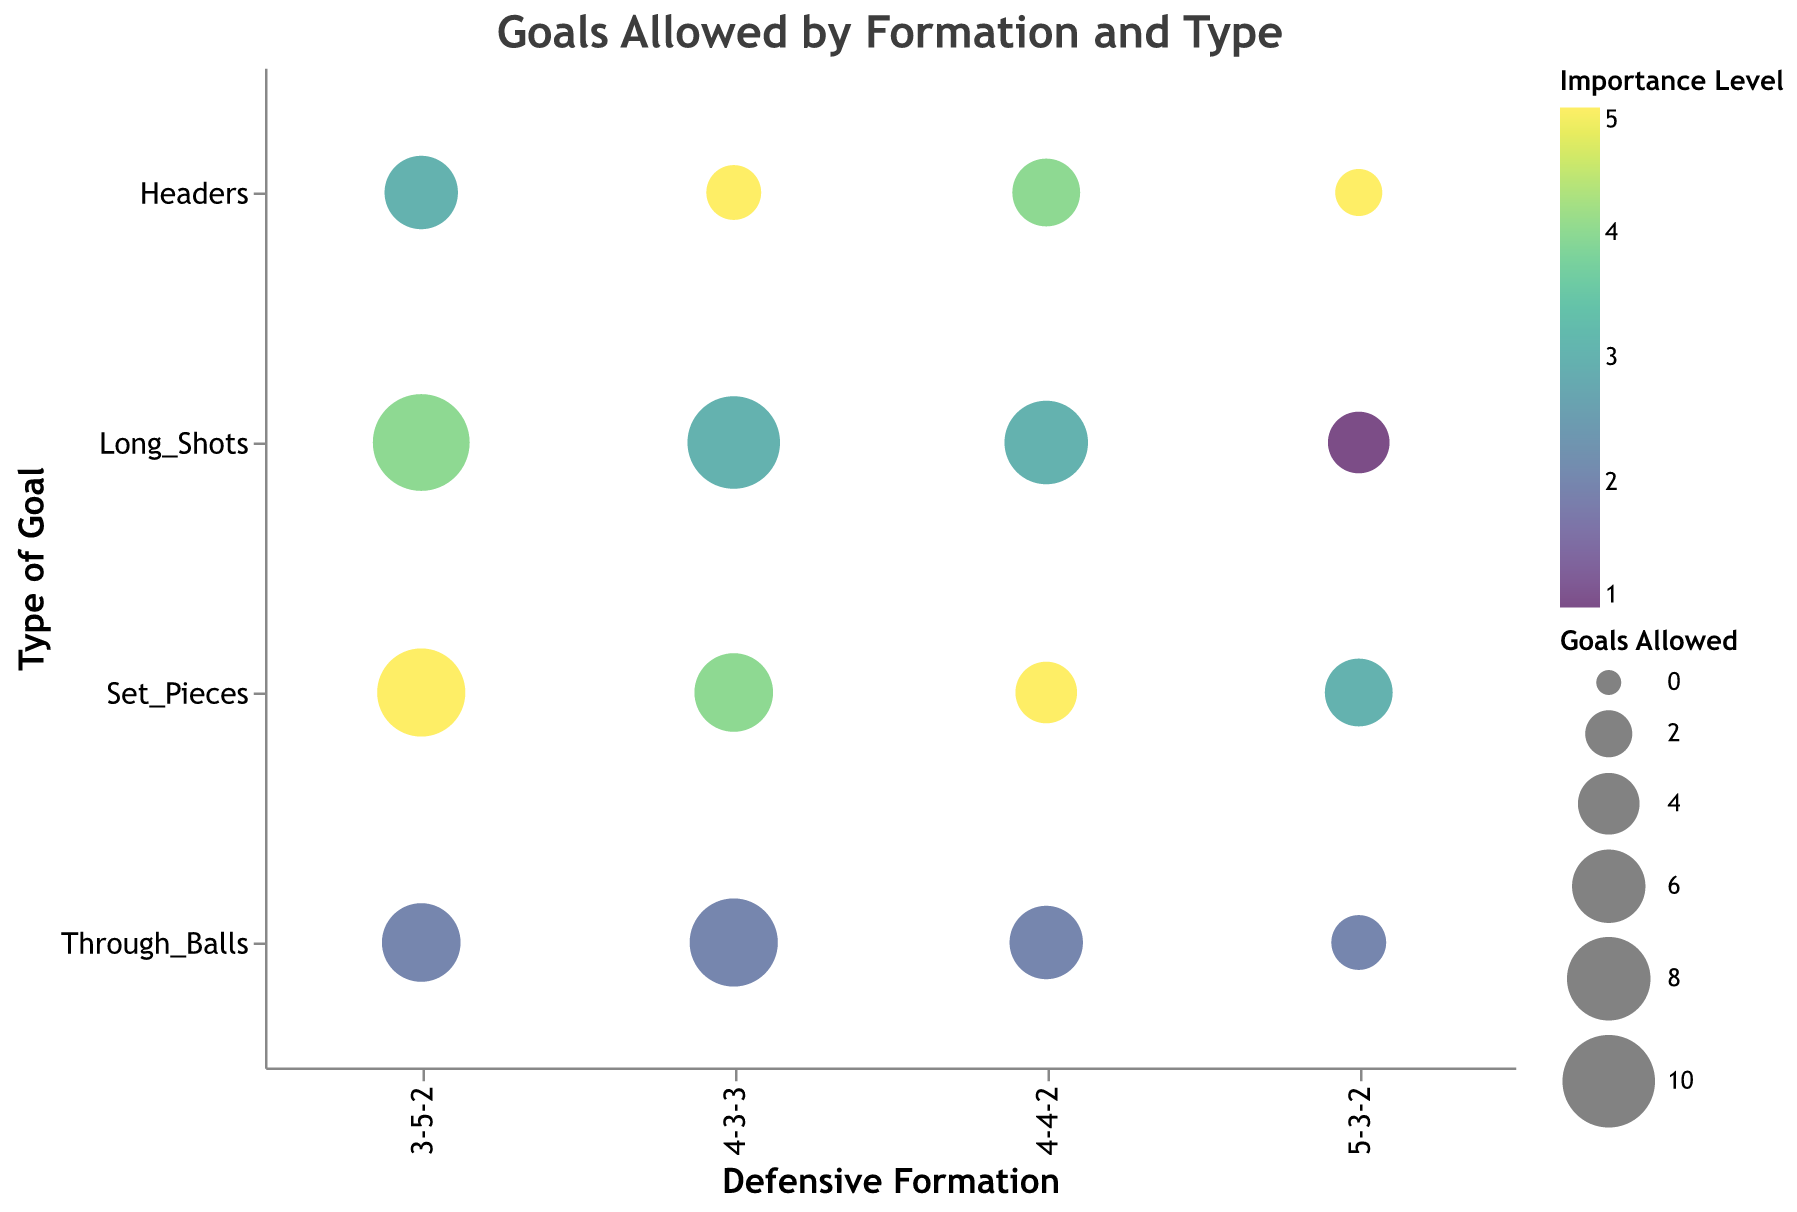What is the title of the figure? The title of the figure is displayed at the top and it reads "Goals Allowed by Formation and Type".
Answer: Goals Allowed by Formation and Type How many goals allowed were from headers in the 4-4-2 formation? Locate the bubble positioned at Formation "4-4-2" and Goal Type "Headers". The size and tooltip indicate it allowed 5 goals.
Answer: 5 Which type of goal allowed has the highest importance level in the 3-5-2 formation? Identify the bubbles within "3-5-2". The largest colored bubble at the intersection with "Set_Pieces" indicates the highest importance level, which is 5.
Answer: Set Pieces Which formation allowed the most goals from long shots? Compare the sizes of the bubbles for "Long_Shots" across formations. The largest bubble is in the "3-5-2" formation with 11 goals allowed.
Answer: 3-5-2 What is the difference in the number of goals allowed from set pieces between the 4-3-3 formation and the 5-3-2 formation? Check the bubbles for "Set_Pieces" in "4-3-3" and "5-3-2". The goals allowed are 7 and 5, respectively. Calculate the difference: 7 - 5 = 2.
Answer: 2 Which formation had the least goals allowed from headers? Look at all bubbles for "Headers" and identify the smallest one. The "5-3-2" formation with 2 goals allowed has the least.
Answer: 5-3-2 Compare the importance levels of through balls between the 4-3-3 formation and the 4-4-2 formation. Which one is higher? Check the color for "Through_Balls" in "4-3-3" and "4-4-2". Importance levels are 2 and 2. Both are equal.
Answer: Equal How many formations allowed more than 5 goals from through balls? Identify the bubbles representing "Through_Balls" and count those with sizes indicating more than 5 goals. "4-3-3", "4-4-2", and "3-5-2" (count is 3).
Answer: 3 What type of goal has the highest importance level in the figure? Examine all bubbles to find the one with the deepest color, which indicates "Set_Pieces" with an importance level of 5, occurring in multiple formations.
Answer: Set Pieces 